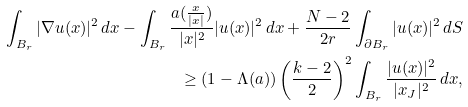<formula> <loc_0><loc_0><loc_500><loc_500>\int _ { B _ { r } } | \nabla u ( x ) | ^ { 2 } \, d x - \int _ { B _ { r } } \frac { a ( \frac { x } { | x | } ) } { | x | ^ { 2 } } | u ( x ) | ^ { 2 } \, d x + \frac { N - 2 } { 2 r } \int _ { \partial B _ { r } } | u ( x ) | ^ { 2 } \, d S \\ \geq ( 1 - \Lambda ( a ) ) \left ( \frac { k - 2 } { 2 } \right ) ^ { 2 } \int _ { B _ { r } } \frac { | u ( x ) | ^ { 2 } } { | x _ { J } | ^ { 2 } } \, d x ,</formula> 